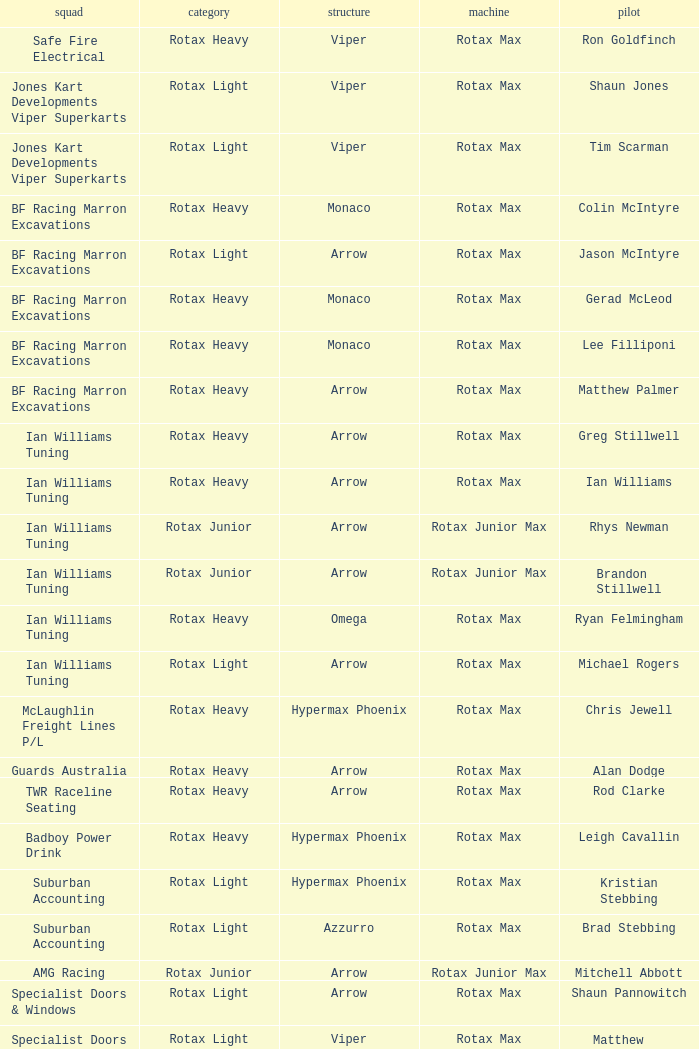What type of engine does the BF Racing Marron Excavations have that also has Monaco as chassis and Lee Filliponi as the driver? Rotax Max. 